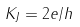<formula> <loc_0><loc_0><loc_500><loc_500>K _ { J } = 2 e / h</formula> 